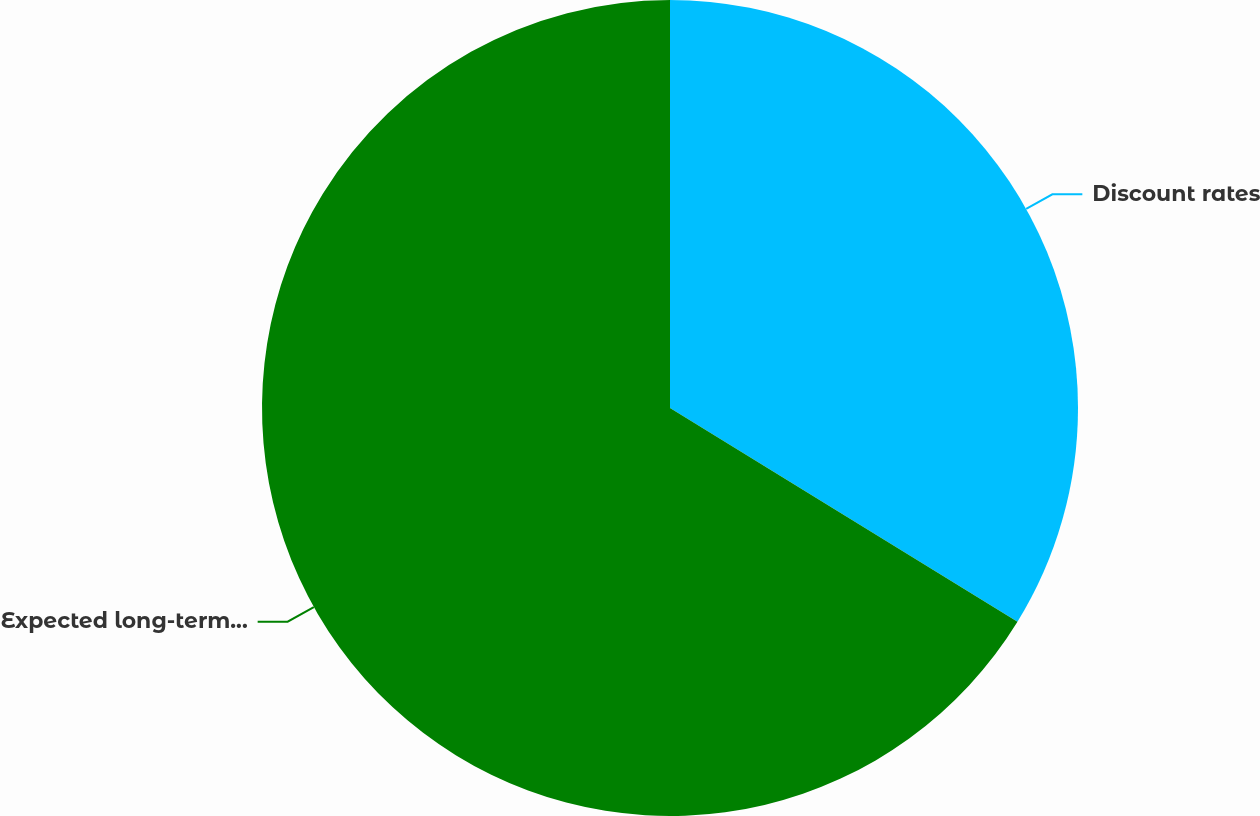Convert chart. <chart><loc_0><loc_0><loc_500><loc_500><pie_chart><fcel>Discount rates<fcel>Expected long-term rates of<nl><fcel>33.78%<fcel>66.22%<nl></chart> 